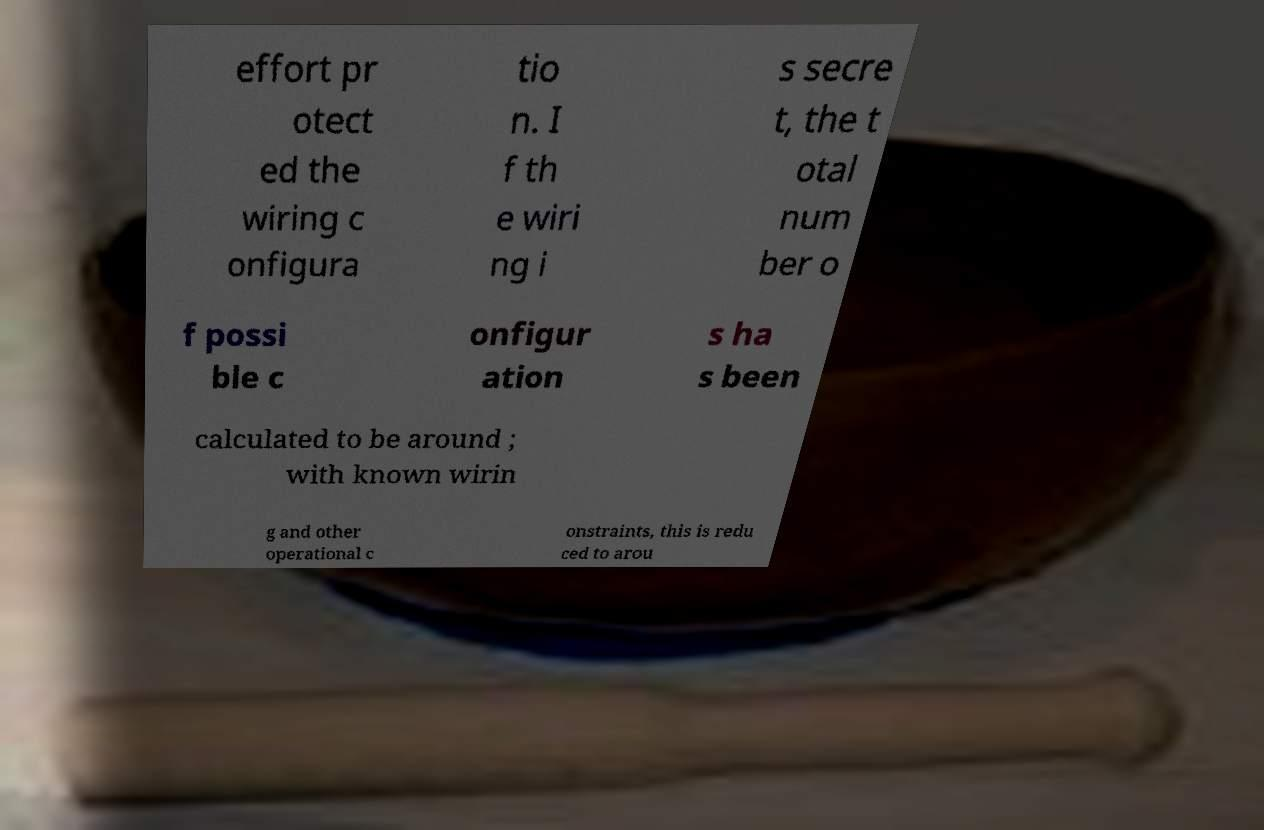Could you extract and type out the text from this image? effort pr otect ed the wiring c onfigura tio n. I f th e wiri ng i s secre t, the t otal num ber o f possi ble c onfigur ation s ha s been calculated to be around ; with known wirin g and other operational c onstraints, this is redu ced to arou 